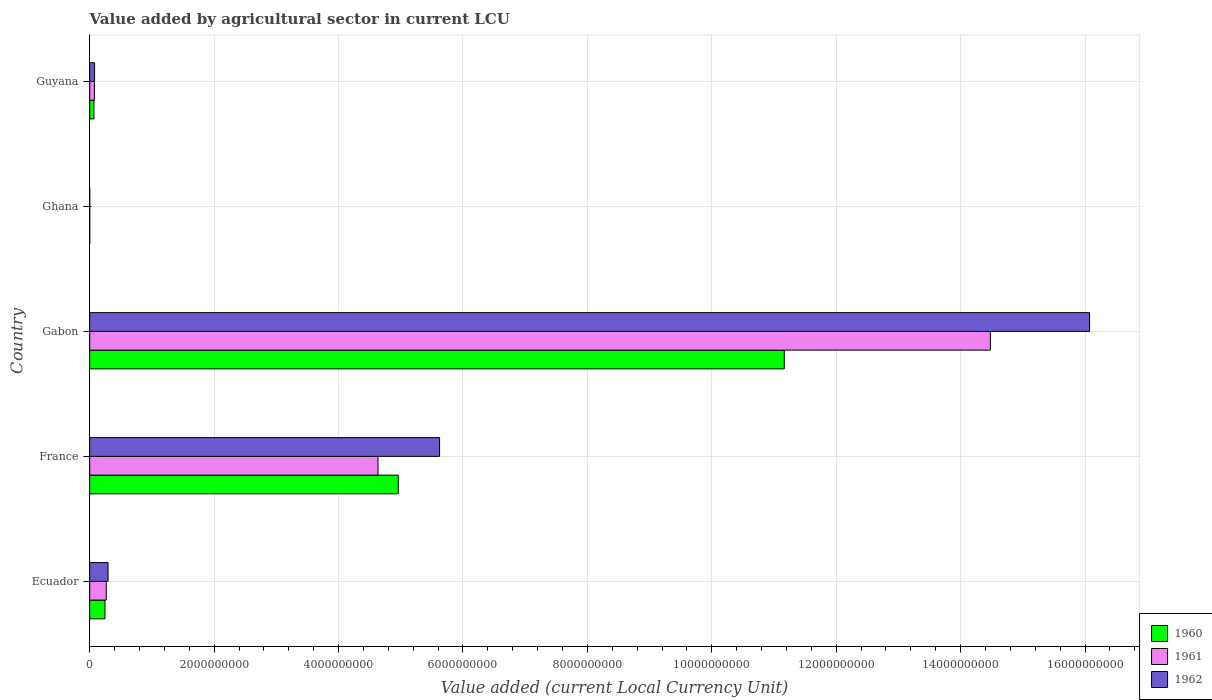How many different coloured bars are there?
Keep it short and to the point. 3. How many groups of bars are there?
Provide a short and direct response. 5. Are the number of bars per tick equal to the number of legend labels?
Give a very brief answer. Yes. How many bars are there on the 1st tick from the top?
Give a very brief answer. 3. What is the label of the 5th group of bars from the top?
Your answer should be compact. Ecuador. What is the value added by agricultural sector in 1960 in Gabon?
Your response must be concise. 1.12e+1. Across all countries, what is the maximum value added by agricultural sector in 1960?
Offer a terse response. 1.12e+1. Across all countries, what is the minimum value added by agricultural sector in 1962?
Offer a very short reply. 3.74e+04. In which country was the value added by agricultural sector in 1962 maximum?
Give a very brief answer. Gabon. In which country was the value added by agricultural sector in 1961 minimum?
Offer a very short reply. Ghana. What is the total value added by agricultural sector in 1960 in the graph?
Provide a short and direct response. 1.64e+1. What is the difference between the value added by agricultural sector in 1961 in France and that in Gabon?
Make the answer very short. -9.84e+09. What is the difference between the value added by agricultural sector in 1960 in Ghana and the value added by agricultural sector in 1962 in Gabon?
Your answer should be very brief. -1.61e+1. What is the average value added by agricultural sector in 1961 per country?
Your response must be concise. 3.89e+09. What is the difference between the value added by agricultural sector in 1962 and value added by agricultural sector in 1961 in Ghana?
Keep it short and to the point. 4500. In how many countries, is the value added by agricultural sector in 1960 greater than 15200000000 LCU?
Provide a succinct answer. 0. What is the ratio of the value added by agricultural sector in 1960 in Gabon to that in Ghana?
Make the answer very short. 3.14e+05. Is the value added by agricultural sector in 1961 in France less than that in Guyana?
Provide a succinct answer. No. What is the difference between the highest and the second highest value added by agricultural sector in 1961?
Ensure brevity in your answer.  9.84e+09. What is the difference between the highest and the lowest value added by agricultural sector in 1960?
Your answer should be compact. 1.12e+1. In how many countries, is the value added by agricultural sector in 1962 greater than the average value added by agricultural sector in 1962 taken over all countries?
Your answer should be compact. 2. How many bars are there?
Provide a short and direct response. 15. Are all the bars in the graph horizontal?
Offer a very short reply. Yes. What is the difference between two consecutive major ticks on the X-axis?
Give a very brief answer. 2.00e+09. Are the values on the major ticks of X-axis written in scientific E-notation?
Your answer should be compact. No. Where does the legend appear in the graph?
Offer a very short reply. Bottom right. What is the title of the graph?
Your response must be concise. Value added by agricultural sector in current LCU. Does "1977" appear as one of the legend labels in the graph?
Give a very brief answer. No. What is the label or title of the X-axis?
Keep it short and to the point. Value added (current Local Currency Unit). What is the label or title of the Y-axis?
Make the answer very short. Country. What is the Value added (current Local Currency Unit) of 1960 in Ecuador?
Keep it short and to the point. 2.45e+08. What is the Value added (current Local Currency Unit) in 1961 in Ecuador?
Give a very brief answer. 2.66e+08. What is the Value added (current Local Currency Unit) of 1962 in Ecuador?
Make the answer very short. 2.95e+08. What is the Value added (current Local Currency Unit) of 1960 in France?
Make the answer very short. 4.96e+09. What is the Value added (current Local Currency Unit) of 1961 in France?
Provide a short and direct response. 4.63e+09. What is the Value added (current Local Currency Unit) in 1962 in France?
Keep it short and to the point. 5.62e+09. What is the Value added (current Local Currency Unit) in 1960 in Gabon?
Your answer should be very brief. 1.12e+1. What is the Value added (current Local Currency Unit) in 1961 in Gabon?
Keep it short and to the point. 1.45e+1. What is the Value added (current Local Currency Unit) of 1962 in Gabon?
Give a very brief answer. 1.61e+1. What is the Value added (current Local Currency Unit) in 1960 in Ghana?
Make the answer very short. 3.55e+04. What is the Value added (current Local Currency Unit) of 1961 in Ghana?
Ensure brevity in your answer.  3.29e+04. What is the Value added (current Local Currency Unit) in 1962 in Ghana?
Your answer should be compact. 3.74e+04. What is the Value added (current Local Currency Unit) of 1960 in Guyana?
Ensure brevity in your answer.  6.88e+07. What is the Value added (current Local Currency Unit) in 1961 in Guyana?
Offer a very short reply. 7.60e+07. What is the Value added (current Local Currency Unit) in 1962 in Guyana?
Provide a short and direct response. 7.84e+07. Across all countries, what is the maximum Value added (current Local Currency Unit) of 1960?
Ensure brevity in your answer.  1.12e+1. Across all countries, what is the maximum Value added (current Local Currency Unit) of 1961?
Give a very brief answer. 1.45e+1. Across all countries, what is the maximum Value added (current Local Currency Unit) of 1962?
Keep it short and to the point. 1.61e+1. Across all countries, what is the minimum Value added (current Local Currency Unit) of 1960?
Keep it short and to the point. 3.55e+04. Across all countries, what is the minimum Value added (current Local Currency Unit) of 1961?
Ensure brevity in your answer.  3.29e+04. Across all countries, what is the minimum Value added (current Local Currency Unit) of 1962?
Your response must be concise. 3.74e+04. What is the total Value added (current Local Currency Unit) of 1960 in the graph?
Offer a very short reply. 1.64e+1. What is the total Value added (current Local Currency Unit) in 1961 in the graph?
Provide a short and direct response. 1.95e+1. What is the total Value added (current Local Currency Unit) of 1962 in the graph?
Your response must be concise. 2.21e+1. What is the difference between the Value added (current Local Currency Unit) of 1960 in Ecuador and that in France?
Offer a very short reply. -4.71e+09. What is the difference between the Value added (current Local Currency Unit) of 1961 in Ecuador and that in France?
Ensure brevity in your answer.  -4.37e+09. What is the difference between the Value added (current Local Currency Unit) in 1962 in Ecuador and that in France?
Make the answer very short. -5.33e+09. What is the difference between the Value added (current Local Currency Unit) of 1960 in Ecuador and that in Gabon?
Your answer should be compact. -1.09e+1. What is the difference between the Value added (current Local Currency Unit) in 1961 in Ecuador and that in Gabon?
Offer a very short reply. -1.42e+1. What is the difference between the Value added (current Local Currency Unit) of 1962 in Ecuador and that in Gabon?
Ensure brevity in your answer.  -1.58e+1. What is the difference between the Value added (current Local Currency Unit) in 1960 in Ecuador and that in Ghana?
Provide a succinct answer. 2.45e+08. What is the difference between the Value added (current Local Currency Unit) of 1961 in Ecuador and that in Ghana?
Provide a short and direct response. 2.66e+08. What is the difference between the Value added (current Local Currency Unit) in 1962 in Ecuador and that in Ghana?
Your answer should be compact. 2.95e+08. What is the difference between the Value added (current Local Currency Unit) of 1960 in Ecuador and that in Guyana?
Keep it short and to the point. 1.76e+08. What is the difference between the Value added (current Local Currency Unit) in 1961 in Ecuador and that in Guyana?
Your answer should be very brief. 1.90e+08. What is the difference between the Value added (current Local Currency Unit) in 1962 in Ecuador and that in Guyana?
Keep it short and to the point. 2.17e+08. What is the difference between the Value added (current Local Currency Unit) of 1960 in France and that in Gabon?
Provide a succinct answer. -6.20e+09. What is the difference between the Value added (current Local Currency Unit) of 1961 in France and that in Gabon?
Provide a short and direct response. -9.84e+09. What is the difference between the Value added (current Local Currency Unit) in 1962 in France and that in Gabon?
Offer a terse response. -1.04e+1. What is the difference between the Value added (current Local Currency Unit) in 1960 in France and that in Ghana?
Give a very brief answer. 4.96e+09. What is the difference between the Value added (current Local Currency Unit) of 1961 in France and that in Ghana?
Your answer should be compact. 4.63e+09. What is the difference between the Value added (current Local Currency Unit) of 1962 in France and that in Ghana?
Your answer should be compact. 5.62e+09. What is the difference between the Value added (current Local Currency Unit) of 1960 in France and that in Guyana?
Make the answer very short. 4.89e+09. What is the difference between the Value added (current Local Currency Unit) in 1961 in France and that in Guyana?
Your response must be concise. 4.56e+09. What is the difference between the Value added (current Local Currency Unit) of 1962 in France and that in Guyana?
Offer a terse response. 5.55e+09. What is the difference between the Value added (current Local Currency Unit) in 1960 in Gabon and that in Ghana?
Provide a succinct answer. 1.12e+1. What is the difference between the Value added (current Local Currency Unit) in 1961 in Gabon and that in Ghana?
Give a very brief answer. 1.45e+1. What is the difference between the Value added (current Local Currency Unit) of 1962 in Gabon and that in Ghana?
Offer a very short reply. 1.61e+1. What is the difference between the Value added (current Local Currency Unit) in 1960 in Gabon and that in Guyana?
Provide a short and direct response. 1.11e+1. What is the difference between the Value added (current Local Currency Unit) of 1961 in Gabon and that in Guyana?
Your answer should be very brief. 1.44e+1. What is the difference between the Value added (current Local Currency Unit) in 1962 in Gabon and that in Guyana?
Provide a succinct answer. 1.60e+1. What is the difference between the Value added (current Local Currency Unit) of 1960 in Ghana and that in Guyana?
Your response must be concise. -6.88e+07. What is the difference between the Value added (current Local Currency Unit) in 1961 in Ghana and that in Guyana?
Make the answer very short. -7.60e+07. What is the difference between the Value added (current Local Currency Unit) in 1962 in Ghana and that in Guyana?
Keep it short and to the point. -7.84e+07. What is the difference between the Value added (current Local Currency Unit) of 1960 in Ecuador and the Value added (current Local Currency Unit) of 1961 in France?
Keep it short and to the point. -4.39e+09. What is the difference between the Value added (current Local Currency Unit) in 1960 in Ecuador and the Value added (current Local Currency Unit) in 1962 in France?
Make the answer very short. -5.38e+09. What is the difference between the Value added (current Local Currency Unit) of 1961 in Ecuador and the Value added (current Local Currency Unit) of 1962 in France?
Your answer should be very brief. -5.36e+09. What is the difference between the Value added (current Local Currency Unit) in 1960 in Ecuador and the Value added (current Local Currency Unit) in 1961 in Gabon?
Offer a terse response. -1.42e+1. What is the difference between the Value added (current Local Currency Unit) in 1960 in Ecuador and the Value added (current Local Currency Unit) in 1962 in Gabon?
Keep it short and to the point. -1.58e+1. What is the difference between the Value added (current Local Currency Unit) in 1961 in Ecuador and the Value added (current Local Currency Unit) in 1962 in Gabon?
Your answer should be compact. -1.58e+1. What is the difference between the Value added (current Local Currency Unit) in 1960 in Ecuador and the Value added (current Local Currency Unit) in 1961 in Ghana?
Your response must be concise. 2.45e+08. What is the difference between the Value added (current Local Currency Unit) in 1960 in Ecuador and the Value added (current Local Currency Unit) in 1962 in Ghana?
Keep it short and to the point. 2.45e+08. What is the difference between the Value added (current Local Currency Unit) of 1961 in Ecuador and the Value added (current Local Currency Unit) of 1962 in Ghana?
Offer a very short reply. 2.66e+08. What is the difference between the Value added (current Local Currency Unit) in 1960 in Ecuador and the Value added (current Local Currency Unit) in 1961 in Guyana?
Your response must be concise. 1.69e+08. What is the difference between the Value added (current Local Currency Unit) in 1960 in Ecuador and the Value added (current Local Currency Unit) in 1962 in Guyana?
Make the answer very short. 1.67e+08. What is the difference between the Value added (current Local Currency Unit) of 1961 in Ecuador and the Value added (current Local Currency Unit) of 1962 in Guyana?
Your response must be concise. 1.88e+08. What is the difference between the Value added (current Local Currency Unit) of 1960 in France and the Value added (current Local Currency Unit) of 1961 in Gabon?
Keep it short and to the point. -9.52e+09. What is the difference between the Value added (current Local Currency Unit) in 1960 in France and the Value added (current Local Currency Unit) in 1962 in Gabon?
Offer a terse response. -1.11e+1. What is the difference between the Value added (current Local Currency Unit) of 1961 in France and the Value added (current Local Currency Unit) of 1962 in Gabon?
Make the answer very short. -1.14e+1. What is the difference between the Value added (current Local Currency Unit) in 1960 in France and the Value added (current Local Currency Unit) in 1961 in Ghana?
Provide a short and direct response. 4.96e+09. What is the difference between the Value added (current Local Currency Unit) in 1960 in France and the Value added (current Local Currency Unit) in 1962 in Ghana?
Your response must be concise. 4.96e+09. What is the difference between the Value added (current Local Currency Unit) in 1961 in France and the Value added (current Local Currency Unit) in 1962 in Ghana?
Your response must be concise. 4.63e+09. What is the difference between the Value added (current Local Currency Unit) of 1960 in France and the Value added (current Local Currency Unit) of 1961 in Guyana?
Your answer should be very brief. 4.88e+09. What is the difference between the Value added (current Local Currency Unit) of 1960 in France and the Value added (current Local Currency Unit) of 1962 in Guyana?
Your answer should be compact. 4.88e+09. What is the difference between the Value added (current Local Currency Unit) in 1961 in France and the Value added (current Local Currency Unit) in 1962 in Guyana?
Keep it short and to the point. 4.56e+09. What is the difference between the Value added (current Local Currency Unit) of 1960 in Gabon and the Value added (current Local Currency Unit) of 1961 in Ghana?
Make the answer very short. 1.12e+1. What is the difference between the Value added (current Local Currency Unit) in 1960 in Gabon and the Value added (current Local Currency Unit) in 1962 in Ghana?
Ensure brevity in your answer.  1.12e+1. What is the difference between the Value added (current Local Currency Unit) of 1961 in Gabon and the Value added (current Local Currency Unit) of 1962 in Ghana?
Keep it short and to the point. 1.45e+1. What is the difference between the Value added (current Local Currency Unit) of 1960 in Gabon and the Value added (current Local Currency Unit) of 1961 in Guyana?
Keep it short and to the point. 1.11e+1. What is the difference between the Value added (current Local Currency Unit) of 1960 in Gabon and the Value added (current Local Currency Unit) of 1962 in Guyana?
Your response must be concise. 1.11e+1. What is the difference between the Value added (current Local Currency Unit) in 1961 in Gabon and the Value added (current Local Currency Unit) in 1962 in Guyana?
Offer a terse response. 1.44e+1. What is the difference between the Value added (current Local Currency Unit) in 1960 in Ghana and the Value added (current Local Currency Unit) in 1961 in Guyana?
Keep it short and to the point. -7.60e+07. What is the difference between the Value added (current Local Currency Unit) in 1960 in Ghana and the Value added (current Local Currency Unit) in 1962 in Guyana?
Offer a very short reply. -7.84e+07. What is the difference between the Value added (current Local Currency Unit) of 1961 in Ghana and the Value added (current Local Currency Unit) of 1962 in Guyana?
Offer a terse response. -7.84e+07. What is the average Value added (current Local Currency Unit) in 1960 per country?
Your response must be concise. 3.29e+09. What is the average Value added (current Local Currency Unit) of 1961 per country?
Offer a terse response. 3.89e+09. What is the average Value added (current Local Currency Unit) of 1962 per country?
Keep it short and to the point. 4.41e+09. What is the difference between the Value added (current Local Currency Unit) of 1960 and Value added (current Local Currency Unit) of 1961 in Ecuador?
Ensure brevity in your answer.  -2.09e+07. What is the difference between the Value added (current Local Currency Unit) of 1960 and Value added (current Local Currency Unit) of 1962 in Ecuador?
Offer a very short reply. -4.98e+07. What is the difference between the Value added (current Local Currency Unit) of 1961 and Value added (current Local Currency Unit) of 1962 in Ecuador?
Keep it short and to the point. -2.89e+07. What is the difference between the Value added (current Local Currency Unit) in 1960 and Value added (current Local Currency Unit) in 1961 in France?
Make the answer very short. 3.26e+08. What is the difference between the Value added (current Local Currency Unit) of 1960 and Value added (current Local Currency Unit) of 1962 in France?
Give a very brief answer. -6.64e+08. What is the difference between the Value added (current Local Currency Unit) in 1961 and Value added (current Local Currency Unit) in 1962 in France?
Your answer should be compact. -9.90e+08. What is the difference between the Value added (current Local Currency Unit) in 1960 and Value added (current Local Currency Unit) in 1961 in Gabon?
Give a very brief answer. -3.31e+09. What is the difference between the Value added (current Local Currency Unit) of 1960 and Value added (current Local Currency Unit) of 1962 in Gabon?
Keep it short and to the point. -4.91e+09. What is the difference between the Value added (current Local Currency Unit) of 1961 and Value added (current Local Currency Unit) of 1962 in Gabon?
Provide a short and direct response. -1.59e+09. What is the difference between the Value added (current Local Currency Unit) of 1960 and Value added (current Local Currency Unit) of 1961 in Ghana?
Make the answer very short. 2600. What is the difference between the Value added (current Local Currency Unit) in 1960 and Value added (current Local Currency Unit) in 1962 in Ghana?
Offer a terse response. -1900. What is the difference between the Value added (current Local Currency Unit) of 1961 and Value added (current Local Currency Unit) of 1962 in Ghana?
Offer a terse response. -4500. What is the difference between the Value added (current Local Currency Unit) in 1960 and Value added (current Local Currency Unit) in 1961 in Guyana?
Provide a short and direct response. -7.20e+06. What is the difference between the Value added (current Local Currency Unit) of 1960 and Value added (current Local Currency Unit) of 1962 in Guyana?
Your response must be concise. -9.60e+06. What is the difference between the Value added (current Local Currency Unit) in 1961 and Value added (current Local Currency Unit) in 1962 in Guyana?
Give a very brief answer. -2.40e+06. What is the ratio of the Value added (current Local Currency Unit) in 1960 in Ecuador to that in France?
Offer a terse response. 0.05. What is the ratio of the Value added (current Local Currency Unit) of 1961 in Ecuador to that in France?
Keep it short and to the point. 0.06. What is the ratio of the Value added (current Local Currency Unit) in 1962 in Ecuador to that in France?
Your response must be concise. 0.05. What is the ratio of the Value added (current Local Currency Unit) of 1960 in Ecuador to that in Gabon?
Ensure brevity in your answer.  0.02. What is the ratio of the Value added (current Local Currency Unit) of 1961 in Ecuador to that in Gabon?
Give a very brief answer. 0.02. What is the ratio of the Value added (current Local Currency Unit) of 1962 in Ecuador to that in Gabon?
Offer a terse response. 0.02. What is the ratio of the Value added (current Local Currency Unit) of 1960 in Ecuador to that in Ghana?
Your answer should be compact. 6909.52. What is the ratio of the Value added (current Local Currency Unit) of 1961 in Ecuador to that in Ghana?
Offer a very short reply. 8090.72. What is the ratio of the Value added (current Local Currency Unit) of 1962 in Ecuador to that in Ghana?
Offer a very short reply. 7888.82. What is the ratio of the Value added (current Local Currency Unit) in 1960 in Ecuador to that in Guyana?
Offer a terse response. 3.57. What is the ratio of the Value added (current Local Currency Unit) in 1961 in Ecuador to that in Guyana?
Offer a terse response. 3.5. What is the ratio of the Value added (current Local Currency Unit) in 1962 in Ecuador to that in Guyana?
Provide a succinct answer. 3.76. What is the ratio of the Value added (current Local Currency Unit) in 1960 in France to that in Gabon?
Give a very brief answer. 0.44. What is the ratio of the Value added (current Local Currency Unit) of 1961 in France to that in Gabon?
Provide a succinct answer. 0.32. What is the ratio of the Value added (current Local Currency Unit) of 1962 in France to that in Gabon?
Make the answer very short. 0.35. What is the ratio of the Value added (current Local Currency Unit) in 1960 in France to that in Ghana?
Give a very brief answer. 1.40e+05. What is the ratio of the Value added (current Local Currency Unit) in 1961 in France to that in Ghana?
Your answer should be very brief. 1.41e+05. What is the ratio of the Value added (current Local Currency Unit) of 1962 in France to that in Ghana?
Ensure brevity in your answer.  1.50e+05. What is the ratio of the Value added (current Local Currency Unit) of 1960 in France to that in Guyana?
Your answer should be compact. 72.09. What is the ratio of the Value added (current Local Currency Unit) in 1961 in France to that in Guyana?
Keep it short and to the point. 60.97. What is the ratio of the Value added (current Local Currency Unit) in 1962 in France to that in Guyana?
Your answer should be very brief. 71.73. What is the ratio of the Value added (current Local Currency Unit) of 1960 in Gabon to that in Ghana?
Give a very brief answer. 3.14e+05. What is the ratio of the Value added (current Local Currency Unit) of 1961 in Gabon to that in Ghana?
Provide a short and direct response. 4.40e+05. What is the ratio of the Value added (current Local Currency Unit) in 1962 in Gabon to that in Ghana?
Provide a succinct answer. 4.30e+05. What is the ratio of the Value added (current Local Currency Unit) in 1960 in Gabon to that in Guyana?
Keep it short and to the point. 162.28. What is the ratio of the Value added (current Local Currency Unit) in 1961 in Gabon to that in Guyana?
Make the answer very short. 190.49. What is the ratio of the Value added (current Local Currency Unit) of 1962 in Gabon to that in Guyana?
Ensure brevity in your answer.  205. What is the ratio of the Value added (current Local Currency Unit) of 1960 in Ghana to that in Guyana?
Offer a terse response. 0. What is the ratio of the Value added (current Local Currency Unit) in 1962 in Ghana to that in Guyana?
Your answer should be compact. 0. What is the difference between the highest and the second highest Value added (current Local Currency Unit) of 1960?
Keep it short and to the point. 6.20e+09. What is the difference between the highest and the second highest Value added (current Local Currency Unit) of 1961?
Ensure brevity in your answer.  9.84e+09. What is the difference between the highest and the second highest Value added (current Local Currency Unit) in 1962?
Ensure brevity in your answer.  1.04e+1. What is the difference between the highest and the lowest Value added (current Local Currency Unit) in 1960?
Provide a short and direct response. 1.12e+1. What is the difference between the highest and the lowest Value added (current Local Currency Unit) of 1961?
Keep it short and to the point. 1.45e+1. What is the difference between the highest and the lowest Value added (current Local Currency Unit) of 1962?
Your answer should be very brief. 1.61e+1. 